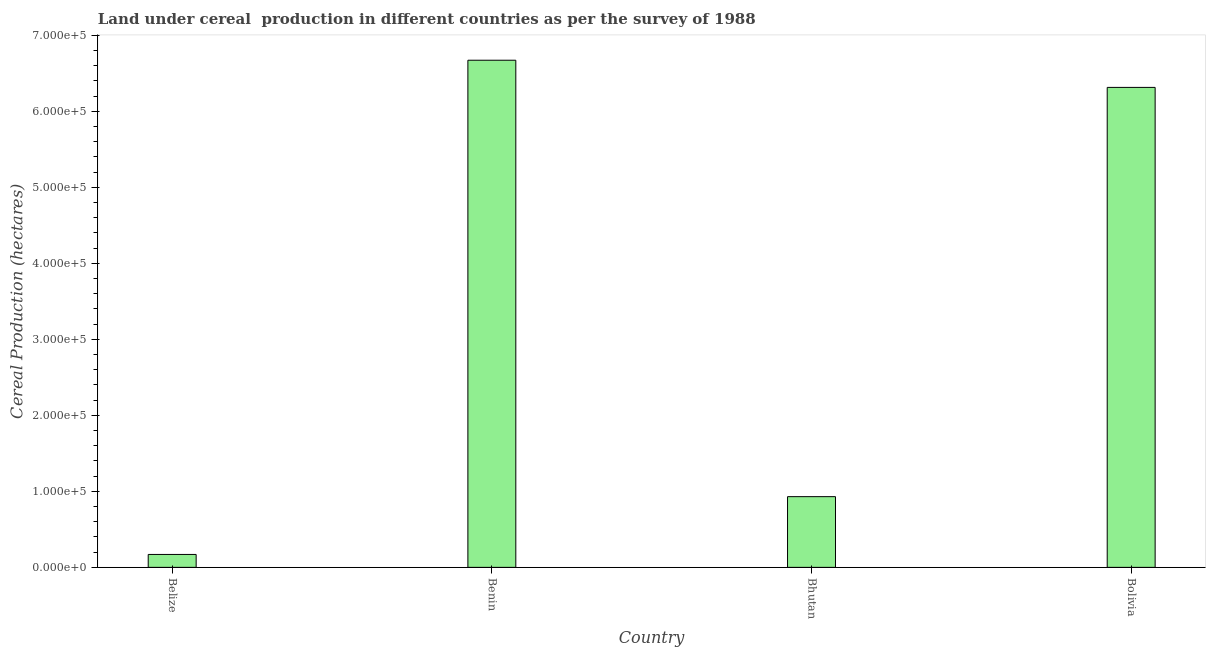Does the graph contain any zero values?
Your answer should be very brief. No. Does the graph contain grids?
Provide a short and direct response. No. What is the title of the graph?
Offer a terse response. Land under cereal  production in different countries as per the survey of 1988. What is the label or title of the Y-axis?
Give a very brief answer. Cereal Production (hectares). What is the land under cereal production in Bhutan?
Give a very brief answer. 9.30e+04. Across all countries, what is the maximum land under cereal production?
Provide a short and direct response. 6.67e+05. Across all countries, what is the minimum land under cereal production?
Offer a terse response. 1.70e+04. In which country was the land under cereal production maximum?
Provide a succinct answer. Benin. In which country was the land under cereal production minimum?
Your answer should be very brief. Belize. What is the sum of the land under cereal production?
Your response must be concise. 1.41e+06. What is the difference between the land under cereal production in Belize and Benin?
Ensure brevity in your answer.  -6.50e+05. What is the average land under cereal production per country?
Provide a succinct answer. 3.52e+05. What is the median land under cereal production?
Your answer should be compact. 3.62e+05. In how many countries, is the land under cereal production greater than 140000 hectares?
Give a very brief answer. 2. What is the ratio of the land under cereal production in Benin to that in Bolivia?
Your answer should be compact. 1.06. Is the difference between the land under cereal production in Bhutan and Bolivia greater than the difference between any two countries?
Provide a short and direct response. No. What is the difference between the highest and the second highest land under cereal production?
Provide a succinct answer. 3.58e+04. What is the difference between the highest and the lowest land under cereal production?
Give a very brief answer. 6.50e+05. How many countries are there in the graph?
Offer a very short reply. 4. What is the difference between two consecutive major ticks on the Y-axis?
Keep it short and to the point. 1.00e+05. What is the Cereal Production (hectares) in Belize?
Ensure brevity in your answer.  1.70e+04. What is the Cereal Production (hectares) in Benin?
Your response must be concise. 6.67e+05. What is the Cereal Production (hectares) of Bhutan?
Provide a short and direct response. 9.30e+04. What is the Cereal Production (hectares) in Bolivia?
Keep it short and to the point. 6.32e+05. What is the difference between the Cereal Production (hectares) in Belize and Benin?
Your answer should be compact. -6.50e+05. What is the difference between the Cereal Production (hectares) in Belize and Bhutan?
Provide a short and direct response. -7.60e+04. What is the difference between the Cereal Production (hectares) in Belize and Bolivia?
Provide a succinct answer. -6.15e+05. What is the difference between the Cereal Production (hectares) in Benin and Bhutan?
Keep it short and to the point. 5.74e+05. What is the difference between the Cereal Production (hectares) in Benin and Bolivia?
Ensure brevity in your answer.  3.58e+04. What is the difference between the Cereal Production (hectares) in Bhutan and Bolivia?
Ensure brevity in your answer.  -5.39e+05. What is the ratio of the Cereal Production (hectares) in Belize to that in Benin?
Ensure brevity in your answer.  0.03. What is the ratio of the Cereal Production (hectares) in Belize to that in Bhutan?
Give a very brief answer. 0.18. What is the ratio of the Cereal Production (hectares) in Belize to that in Bolivia?
Your response must be concise. 0.03. What is the ratio of the Cereal Production (hectares) in Benin to that in Bhutan?
Provide a short and direct response. 7.17. What is the ratio of the Cereal Production (hectares) in Benin to that in Bolivia?
Offer a very short reply. 1.06. What is the ratio of the Cereal Production (hectares) in Bhutan to that in Bolivia?
Your answer should be very brief. 0.15. 